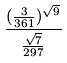Convert formula to latex. <formula><loc_0><loc_0><loc_500><loc_500>\frac { ( \frac { 3 } { 3 6 1 } ) ^ { \sqrt { 9 } } } { \frac { \sqrt { 7 } } { 2 9 7 } }</formula> 